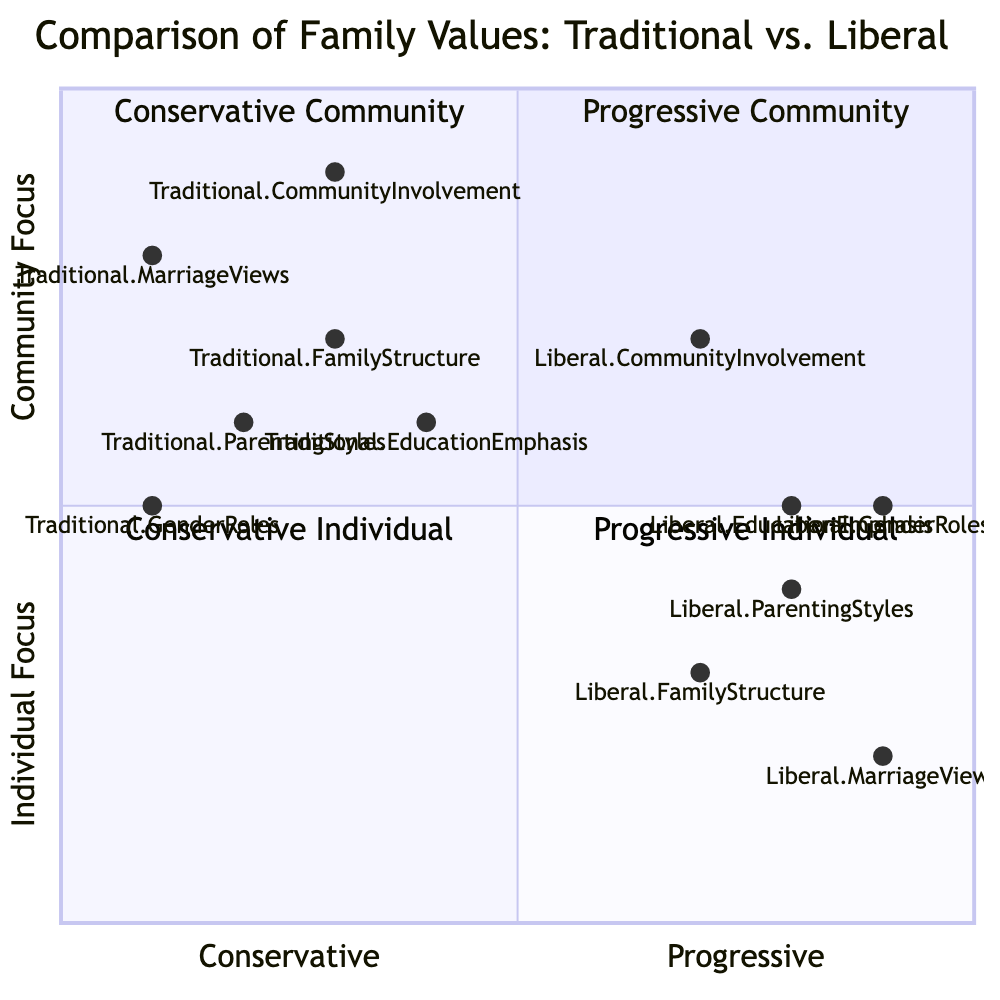What is the y-axis label of the diagram? The y-axis of the diagram is labeled "Individual Focus --> Community Focus," which indicates how the values are spread in relation to focus on individuals versus the community.
Answer: Individual Focus --> Community Focus Which quadrant contains Traditional Marriage Views? Traditional Marriage Views is located in Quadrant 2, which is categorized as "Conservative Community." This can be determined by its coordinates [0.1, 0.8], placing it in that quadrant.
Answer: Quadrant 2 What is the trend of Liberal Community Involvement compared to Traditional Community Involvement? Liberal Community Involvement has coordinates [0.7, 0.7] while Traditional Community Involvement has coordinates [0.3, 0.9]. This shows that although Liberal is more individualistic on the y-axis, it has a higher measure on the x-axis, indicating a more progressive community engagement.
Answer: More progressive How many values are in the Conservative Individual quadrant? The Conservative Individual quadrant, Quadrant 3, does not contain any nodes as no values were placed within it according to the provided data, indicating that no values align with conservative individual focus in this context.
Answer: 0 Which Parenting Style is situated the furthest to the right on the x-axis? Liberal Parenting Styles has coordinates [0.8, 0.4], making it the furthest right on the x-axis as compared to any other parenting style, as traditional values are consistently lower on this scale.
Answer: Liberal Parenting Styles Which value has the highest individual focus ranking? Traditional Marriage Views scores the highest on the y-axis with a value of 0.8, indicating it has the strongest focus on community among all the traditional values.
Answer: Traditional Marriage Views In which quadrant does Traditional Gender Roles reside? Traditional Gender Roles is located in Quadrant 2, indicated by the coordinates [0.1, 0.5]. Since this quadrant is characterized as "Conservative Community," Traditional Gender Roles fits within that definition.
Answer: Quadrant 2 Which category has the most similar individual focus between Traditional and Liberal? Traditional Education Emphasis [0.4, 0.6] and Liberal Education Emphasis [0.8, 0.5] show a similar individual focus according to their coordinates being quite close on the y-axis, indicating a convergence in education values despite differing approaches.
Answer: Education Emphasis 